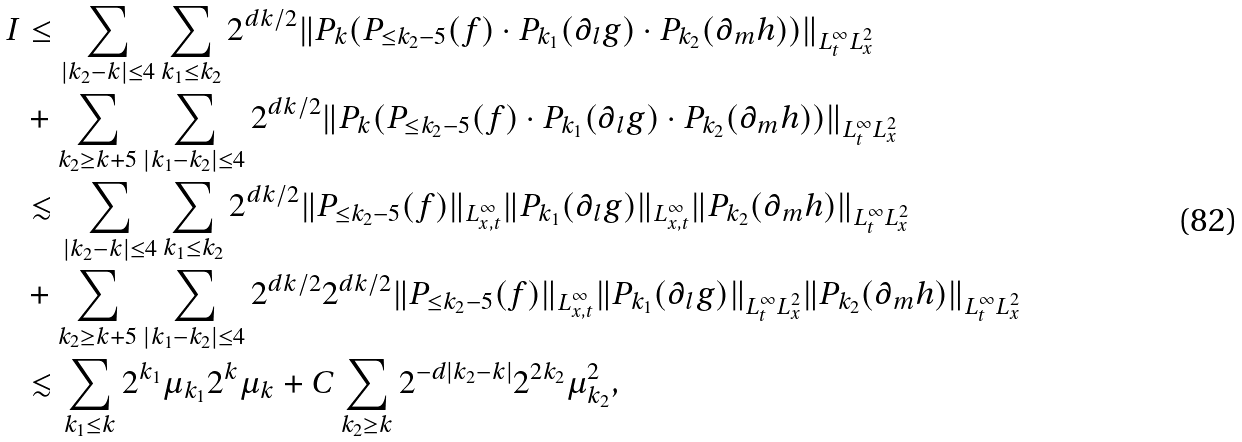Convert formula to latex. <formula><loc_0><loc_0><loc_500><loc_500>I & \leq \sum _ { | k _ { 2 } - k | \leq 4 } \sum _ { k _ { 1 } \leq k _ { 2 } } 2 ^ { d k / 2 } \| P _ { k } ( P _ { \leq k _ { 2 } - 5 } ( f ) \cdot P _ { k _ { 1 } } ( \partial _ { l } g ) \cdot P _ { k _ { 2 } } ( \partial _ { m } h ) ) \| _ { L ^ { \infty } _ { t } L ^ { 2 } _ { x } } \\ & + \sum _ { k _ { 2 } \geq k + 5 } \sum _ { | k _ { 1 } - k _ { 2 } | \leq 4 } 2 ^ { d k / 2 } \| P _ { k } ( P _ { \leq k _ { 2 } - 5 } ( f ) \cdot P _ { k _ { 1 } } ( \partial _ { l } g ) \cdot P _ { k _ { 2 } } ( \partial _ { m } h ) ) \| _ { L ^ { \infty } _ { t } L ^ { 2 } _ { x } } \\ & \lesssim \sum _ { | k _ { 2 } - k | \leq 4 } \sum _ { k _ { 1 } \leq k _ { 2 } } 2 ^ { d k / 2 } \| P _ { \leq k _ { 2 } - 5 } ( f ) \| _ { L ^ { \infty } _ { x , t } } \| P _ { k _ { 1 } } ( \partial _ { l } g ) \| _ { L ^ { \infty } _ { x , t } } \| P _ { k _ { 2 } } ( \partial _ { m } h ) \| _ { L ^ { \infty } _ { t } L ^ { 2 } _ { x } } \\ & + \sum _ { k _ { 2 } \geq k + 5 } \sum _ { | k _ { 1 } - k _ { 2 } | \leq 4 } 2 ^ { d k / 2 } 2 ^ { d k / 2 } \| P _ { \leq k _ { 2 } - 5 } ( f ) \| _ { L ^ { \infty } _ { x , t } } \| P _ { k _ { 1 } } ( \partial _ { l } g ) \| _ { L ^ { \infty } _ { t } L ^ { 2 } _ { x } } \| P _ { k _ { 2 } } ( \partial _ { m } h ) \| _ { L ^ { \infty } _ { t } L ^ { 2 } _ { x } } \\ & \lesssim \sum _ { k _ { 1 } \leq k } 2 ^ { k _ { 1 } } \mu _ { k _ { 1 } } 2 ^ { k } \mu _ { k } + C \sum _ { k _ { 2 } \geq k } 2 ^ { - d | k _ { 2 } - k | } 2 ^ { 2 k _ { 2 } } \mu _ { k _ { 2 } } ^ { 2 } ,</formula> 